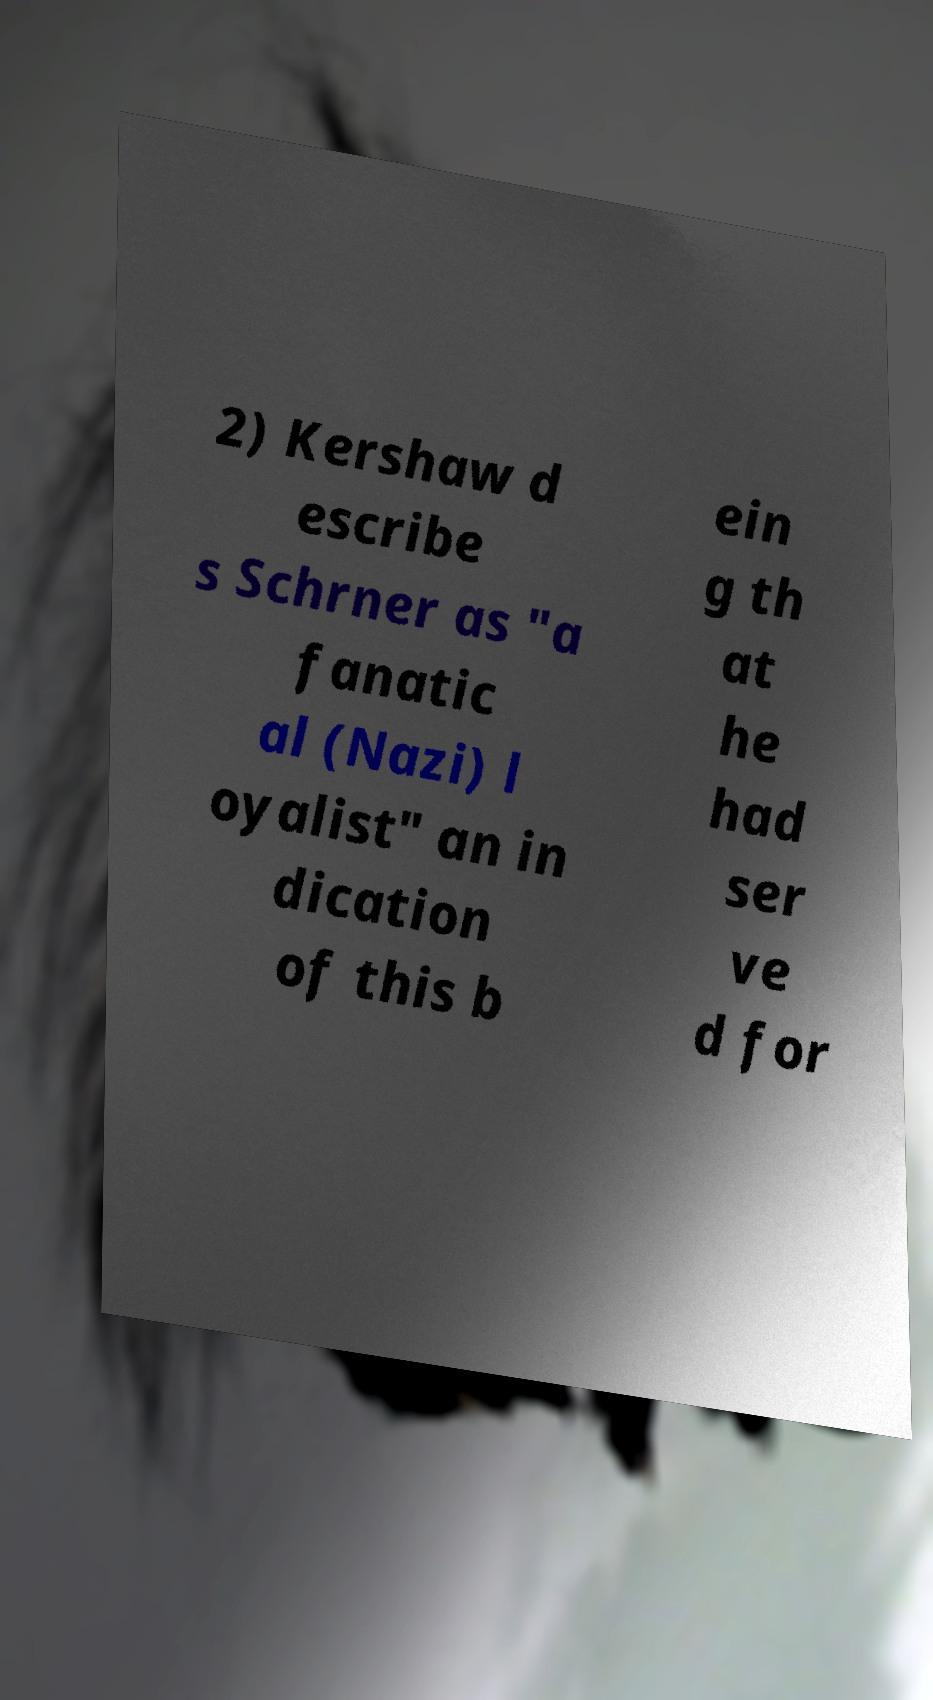Can you read and provide the text displayed in the image?This photo seems to have some interesting text. Can you extract and type it out for me? 2) Kershaw d escribe s Schrner as "a fanatic al (Nazi) l oyalist" an in dication of this b ein g th at he had ser ve d for 